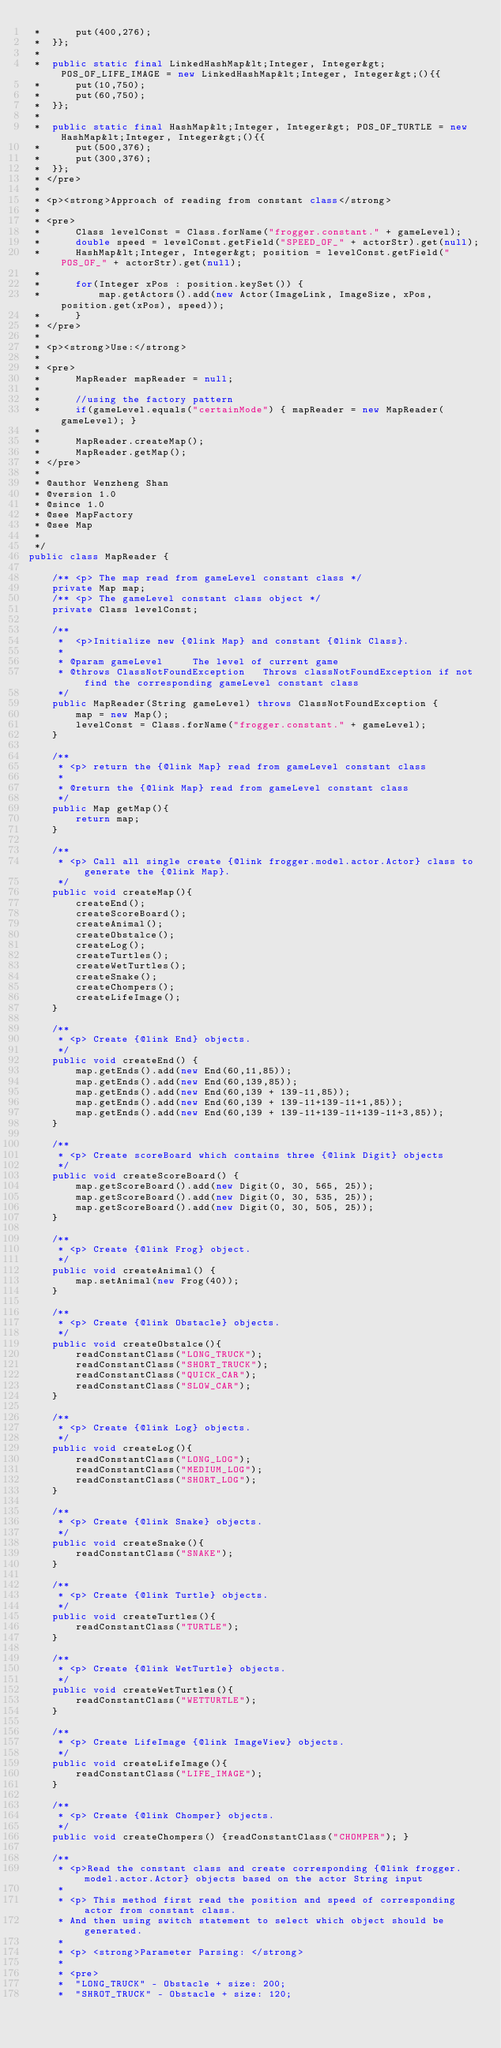Convert code to text. <code><loc_0><loc_0><loc_500><loc_500><_Java_> *		put(400,276);
 *	}};
 *	
 *	public static final LinkedHashMap&lt;Integer, Integer&gt; POS_OF_LIFE_IMAGE = new LinkedHashMap&lt;Integer, Integer&gt;(){{
 *		put(10,750);
 *		put(60,750);
 *	}};
 *	
 *	public static final HashMap&lt;Integer, Integer&gt; POS_OF_TURTLE = new HashMap&lt;Integer, Integer&gt;(){{
 *		put(500,376);
 *		put(300,376);
 *	}};
 * </pre>
 * 
 * <p><strong>Approach of reading from constant class</strong>
 * 
 * <pre>
 * 		Class levelConst = Class.forName("frogger.constant." + gameLevel);
 * 		double speed = levelConst.getField("SPEED_OF_" + actorStr).get(null);
 * 		HashMap&lt;Integer, Integer&gt; position = levelConst.getField("POS_OF_" + actorStr).get(null);
 * 
 * 		for(Integer xPos : position.keySet()) {
 *			map.getActors().add(new Actor(ImageLink, ImageSize, xPos, position.get(xPos), speed));
 *		}
 * </pre>
 * 
 * <p><strong>Use:</strong>
 * 
 * <pre>
 * 		MapReader mapReader = null;
 * 
 * 		//using the factory pattern
 * 		if(gameLevel.equals("certainMode") { mapReader = new MapReader(gameLevel); } 
 * 		
 * 		MapReader.createMap();
 * 		MapReader.getMap();
 * </pre>
 * 
 * @author Wenzheng Shan
 * @version 1.0
 * @since 1.0
 * @see MapFactory
 * @see Map
 *
 */
public class MapReader {
	
	/** <p> The map read from gameLevel constant class */
	private Map map;
	/** <p> The gameLevel constant class object */
	private Class levelConst;
	
	/**
	 * 	<p>Initialize new {@link Map} and constant {@link Class}.
	 * 
	 * @param gameLevel		The level of current game
	 * @throws ClassNotFoundException	Throws classNotFoundException if not find the corresponding gameLevel constant class
	 */
	public MapReader(String gameLevel) throws ClassNotFoundException {
		map = new Map();
		levelConst = Class.forName("frogger.constant." + gameLevel);
	}
	
	/**
	 * <p> return the {@link Map} read from gameLevel constant class
	 * 
	 * @return the {@link Map} read from gameLevel constant class
	 */
	public Map getMap(){
		return map;
	}
	
	/**
	 * <p> Call all single create {@link frogger.model.actor.Actor} class to generate the {@link Map}.
	 */
	public void createMap(){
		createEnd();
		createScoreBoard();
		createAnimal();
		createObstalce();
		createLog();
		createTurtles();
		createWetTurtles();
		createSnake();
		createChompers();
		createLifeImage();
	}
	
	/**
	 * <p> Create {@link End} objects.
	 */
	public void createEnd() {
		map.getEnds().add(new End(60,11,85));
		map.getEnds().add(new End(60,139,85));
		map.getEnds().add(new End(60,139 + 139-11,85));
		map.getEnds().add(new End(60,139 + 139-11+139-11+1,85));
		map.getEnds().add(new End(60,139 + 139-11+139-11+139-11+3,85));
	}
	
	/**
	 * <p> Create scoreBoard which contains three {@link Digit} objects
	 */
	public void createScoreBoard() {
		map.getScoreBoard().add(new Digit(0, 30, 565, 25));
		map.getScoreBoard().add(new Digit(0, 30, 535, 25));
		map.getScoreBoard().add(new Digit(0, 30, 505, 25));
	}
	
	/**
	 * <p> Create {@link Frog} object.
	 */
	public void createAnimal() {
		map.setAnimal(new Frog(40));
	}
	
	/**
	 * <p> Create {@link Obstacle} objects.
	 */
	public void createObstalce(){
		readConstantClass("LONG_TRUCK");
		readConstantClass("SHORT_TRUCK");
		readConstantClass("QUICK_CAR");
		readConstantClass("SLOW_CAR");
	}
	
	/**
	 * <p> Create {@link Log} objects.
	 */
	public void createLog(){
		readConstantClass("LONG_LOG");
		readConstantClass("MEDIUM_LOG");
		readConstantClass("SHORT_LOG");
	}

	/**
	 * <p> Create {@link Snake} objects.
	 */
	public void createSnake(){
		readConstantClass("SNAKE");
	}
	
	/**
	 * <p> Create {@link Turtle} objects.
	 */
	public void createTurtles(){
		readConstantClass("TURTLE");
	}
	
	/**
	 * <p> Create {@link WetTurtle} objects.
	 */
	public void createWetTurtles(){
		readConstantClass("WETTURTLE");
	}

	/**
	 * <p> Create LifeImage {@link ImageView} objects.
	 */
	public void createLifeImage(){
		readConstantClass("LIFE_IMAGE");
	}

	/**
	 * <p> Create {@link Chomper} objects.
	 */
	public void createChompers() {readConstantClass("CHOMPER"); }
	
	/**
	 * <p>Read the constant class and create corresponding {@link frogger.model.actor.Actor} objects based on the actor String input 
	 * 
	 * <p> This method first read the position and speed of corresponding actor from constant class. 
	 * And then using switch statement to select which object should be generated.
	 * 
	 * <p> <strong>Parameter Parsing: </strong>
	 * 
	 * <pre>
	 * 	"LONG_TRUCK" - Obstacle + size: 200;
	 * 	"SHROT_TRUCK" - Obstacle + size: 120;</code> 